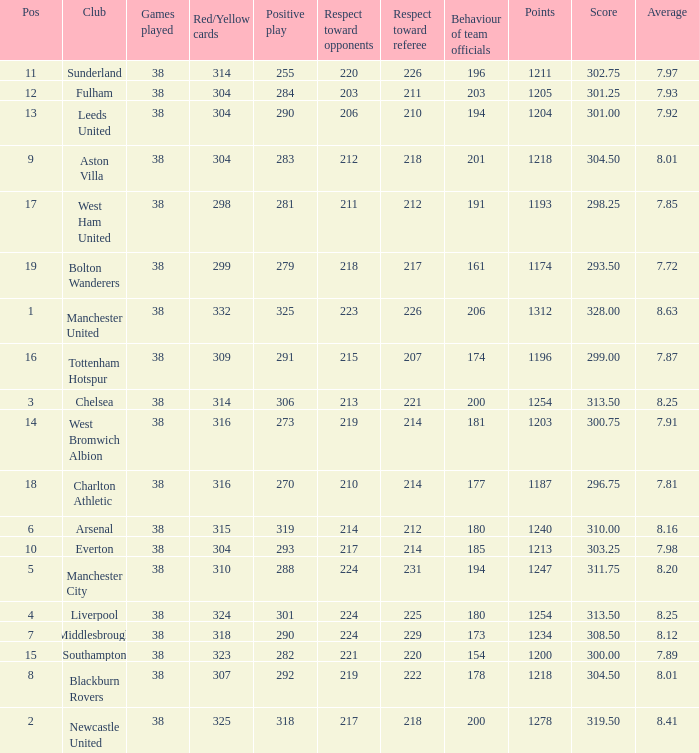Name the most red/yellow cards for positive play being 255 314.0. 